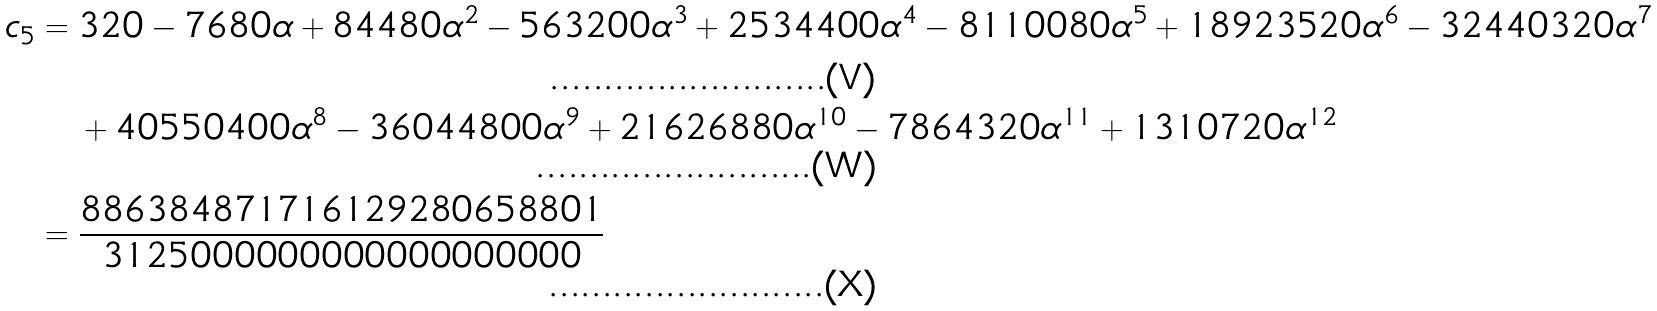<formula> <loc_0><loc_0><loc_500><loc_500>c _ { 5 } & = 3 2 0 - 7 6 8 0 \alpha + 8 4 4 8 0 \alpha ^ { 2 } - 5 6 3 2 0 0 \alpha ^ { 3 } + 2 5 3 4 4 0 0 \alpha ^ { 4 } - 8 1 1 0 0 8 0 \alpha ^ { 5 } + 1 8 9 2 3 5 2 0 \alpha ^ { 6 } - 3 2 4 4 0 3 2 0 \alpha ^ { 7 } \\ & \quad + 4 0 5 5 0 4 0 0 \alpha ^ { 8 } - 3 6 0 4 4 8 0 0 \alpha ^ { 9 } + 2 1 6 2 6 8 8 0 \alpha ^ { 1 0 } - 7 8 6 4 3 2 0 \alpha ^ { 1 1 } + 1 3 1 0 7 2 0 \alpha ^ { 1 2 } \\ & = \frac { 8 8 6 3 8 4 8 7 1 7 1 6 1 2 9 2 8 0 6 5 8 8 0 1 } { 3 1 2 5 0 0 0 0 0 0 0 0 0 0 0 0 0 0 0 0 0 0 }</formula> 